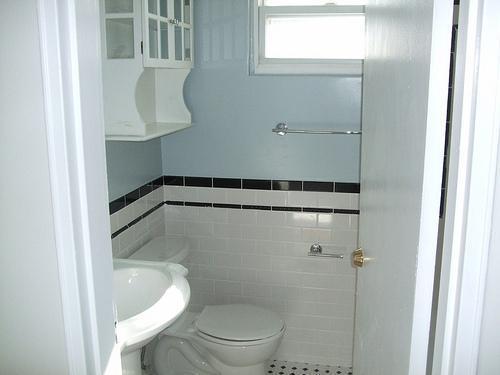How many windows are in the room?
Give a very brief answer. 1. 